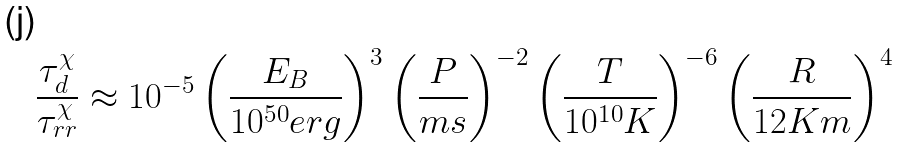Convert formula to latex. <formula><loc_0><loc_0><loc_500><loc_500>\frac { \tau ^ { \chi } _ { d } } { \tau ^ { \chi } _ { r r } } \approx 1 0 ^ { - 5 } \left ( \frac { E _ { B } } { 1 0 ^ { 5 0 } e r g } \right ) ^ { 3 } \left ( \frac { P } { m s } \right ) ^ { - 2 } \left ( \frac { T } { 1 0 ^ { 1 0 } K } \right ) ^ { - 6 } \left ( \frac { R } { 1 2 K m } \right ) ^ { 4 }</formula> 